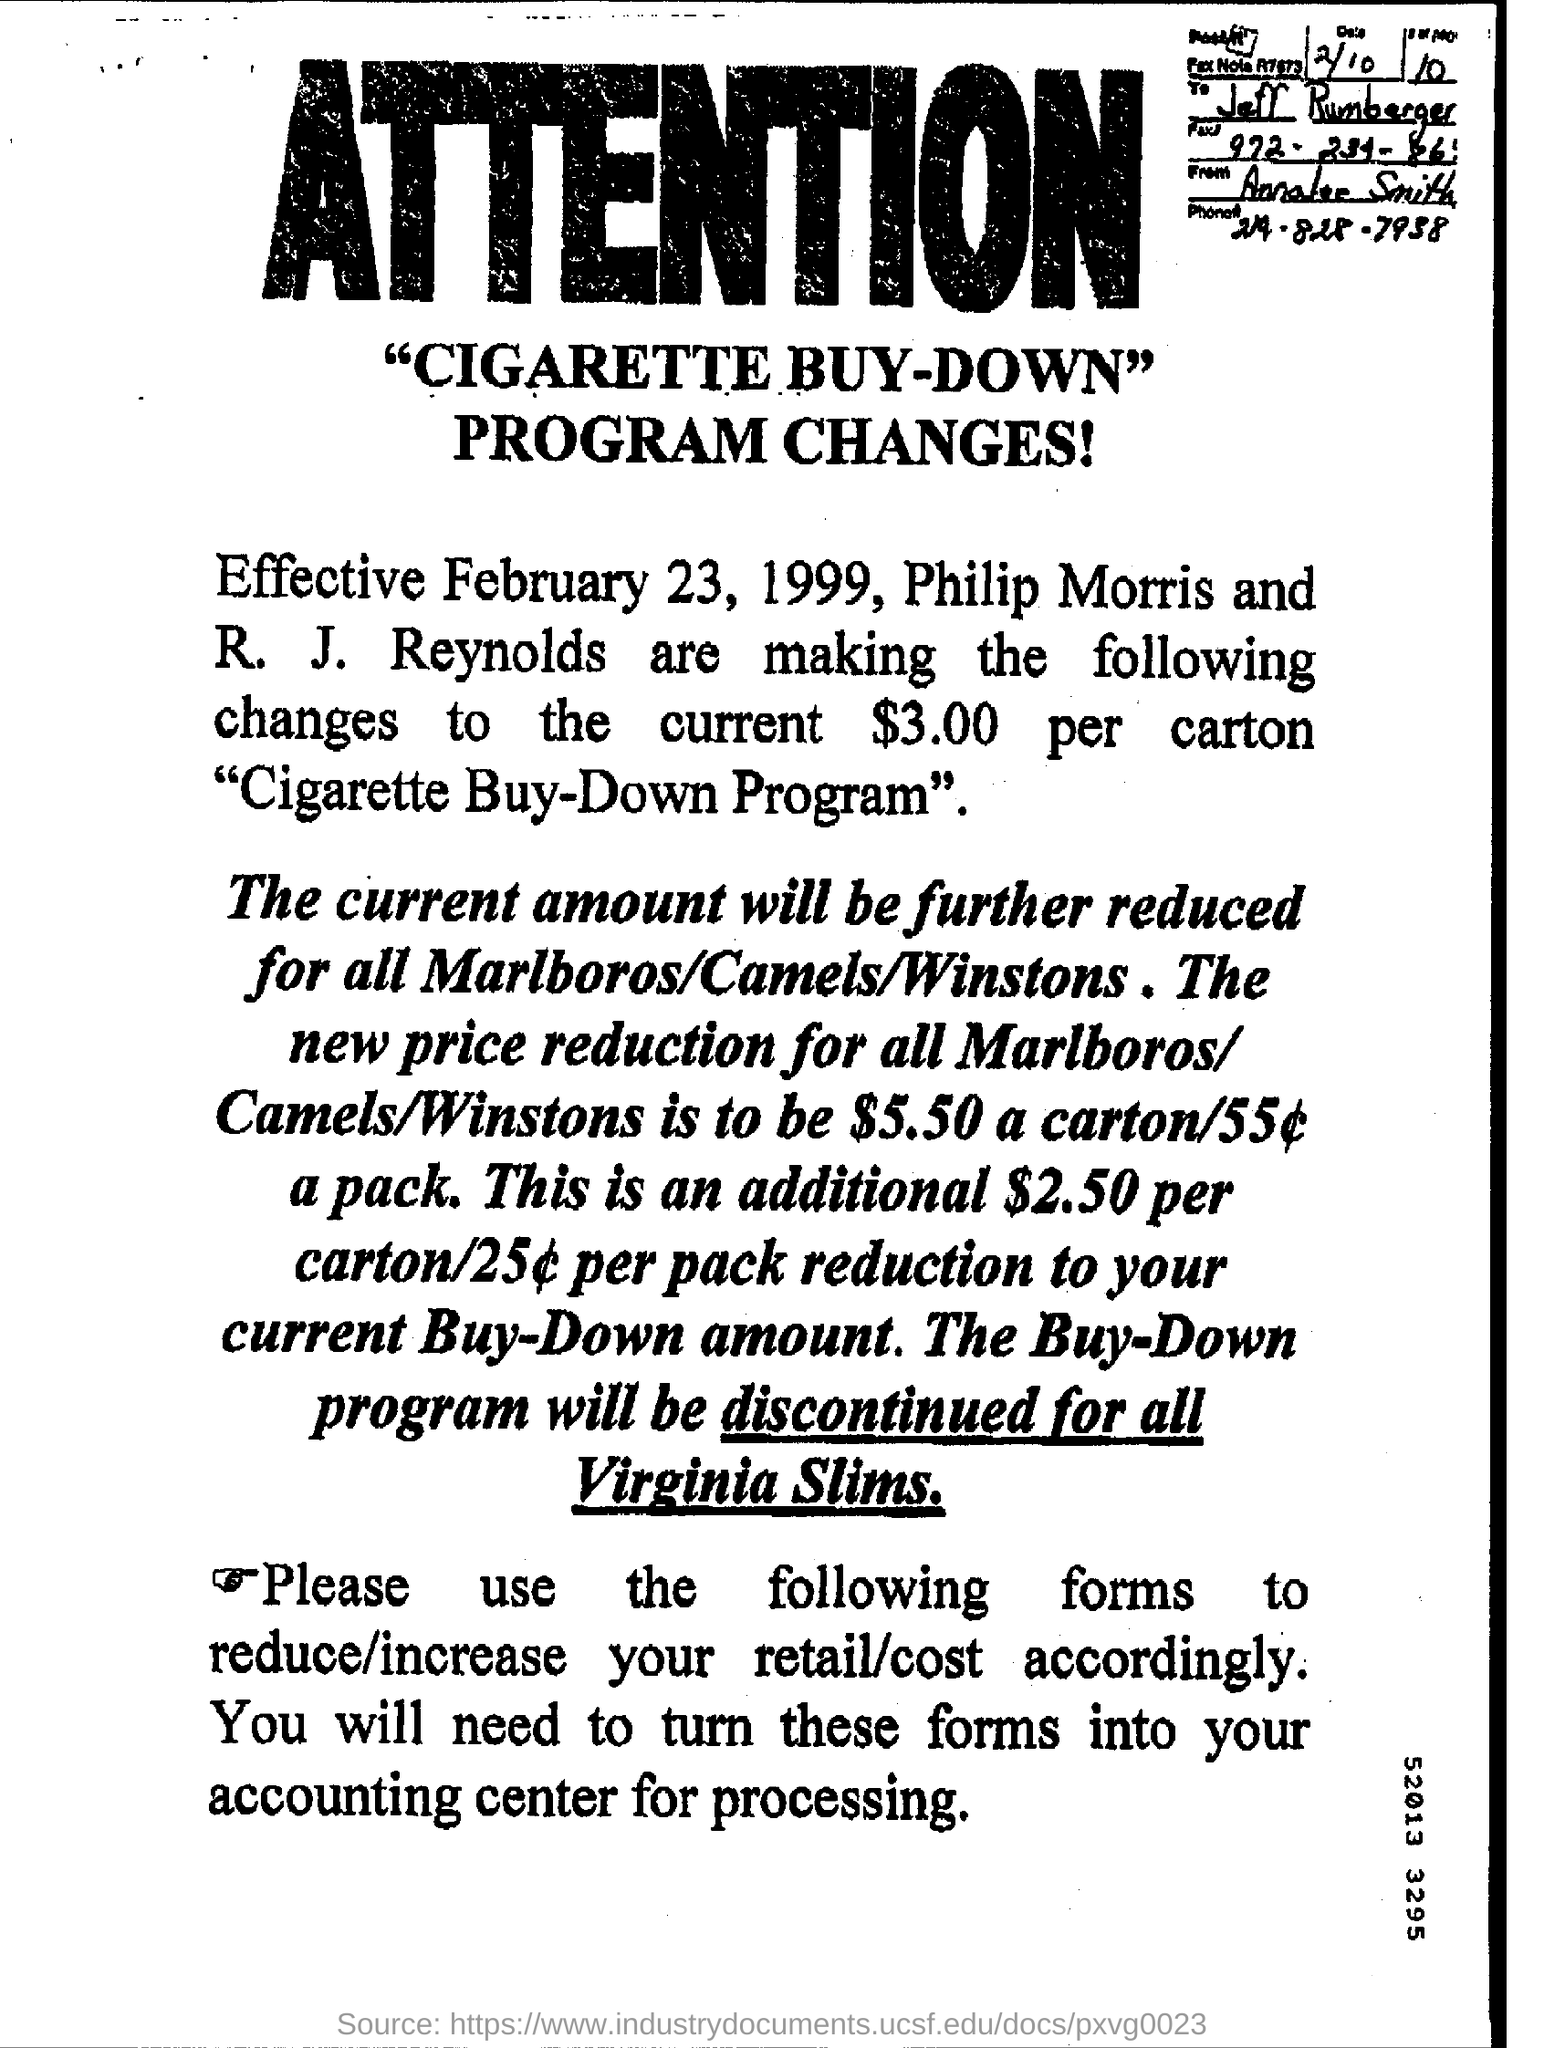When is the program change effective from?
Provide a short and direct response. Effective February 23, 1999. For which items will the current amount be further reduced?
Your response must be concise. All marlboros/camels/winstons. What is the new price reduction for all Marlboros/Camels/Winstons?
Your answer should be compact. $5.50. For which items will the Buy-Down Program be discontinued?
Your response must be concise. Virginia slims. Who is the note addressed to?
Your answer should be compact. Jeff Rumberger. What is the phone number given?
Make the answer very short. 219-828-7938. 